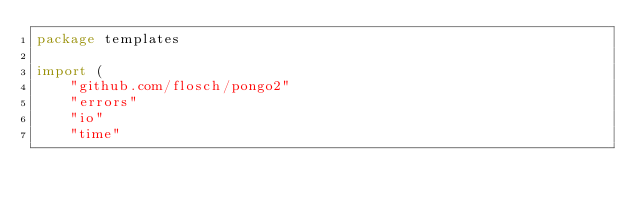<code> <loc_0><loc_0><loc_500><loc_500><_Go_>package templates

import (
	"github.com/flosch/pongo2"
	"errors"
	"io"
	"time"</code> 